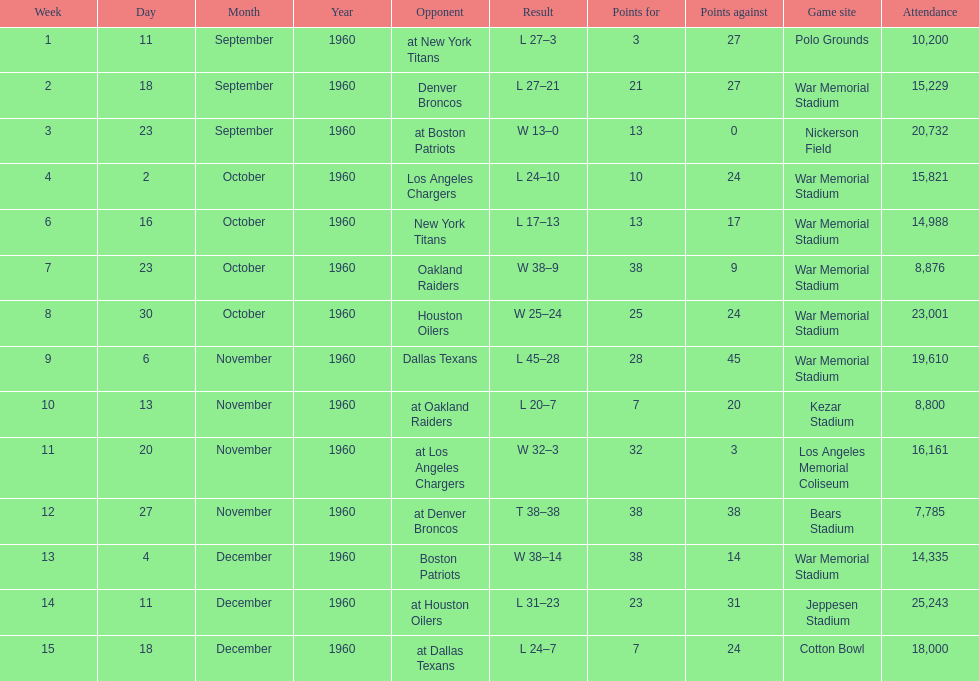Who was the opponent during for first week? New York Titans. 